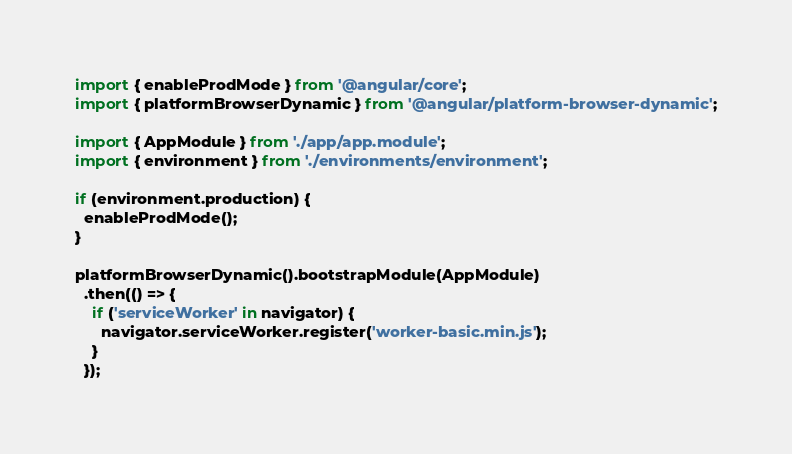<code> <loc_0><loc_0><loc_500><loc_500><_TypeScript_>import { enableProdMode } from '@angular/core';
import { platformBrowserDynamic } from '@angular/platform-browser-dynamic';

import { AppModule } from './app/app.module';
import { environment } from './environments/environment';

if (environment.production) {
  enableProdMode();
}

platformBrowserDynamic().bootstrapModule(AppModule)
  .then(() => {
    if ('serviceWorker' in navigator) {
      navigator.serviceWorker.register('worker-basic.min.js');
    }
  });
</code> 